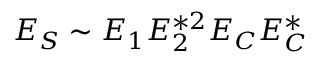Convert formula to latex. <formula><loc_0><loc_0><loc_500><loc_500>E _ { S } \sim E _ { 1 } E _ { 2 } ^ { * 2 } E _ { C } E _ { C } ^ { * }</formula> 